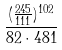Convert formula to latex. <formula><loc_0><loc_0><loc_500><loc_500>\frac { ( \frac { 2 4 5 } { 1 1 1 } ) ^ { 1 0 2 } } { 8 2 \cdot 4 8 1 }</formula> 